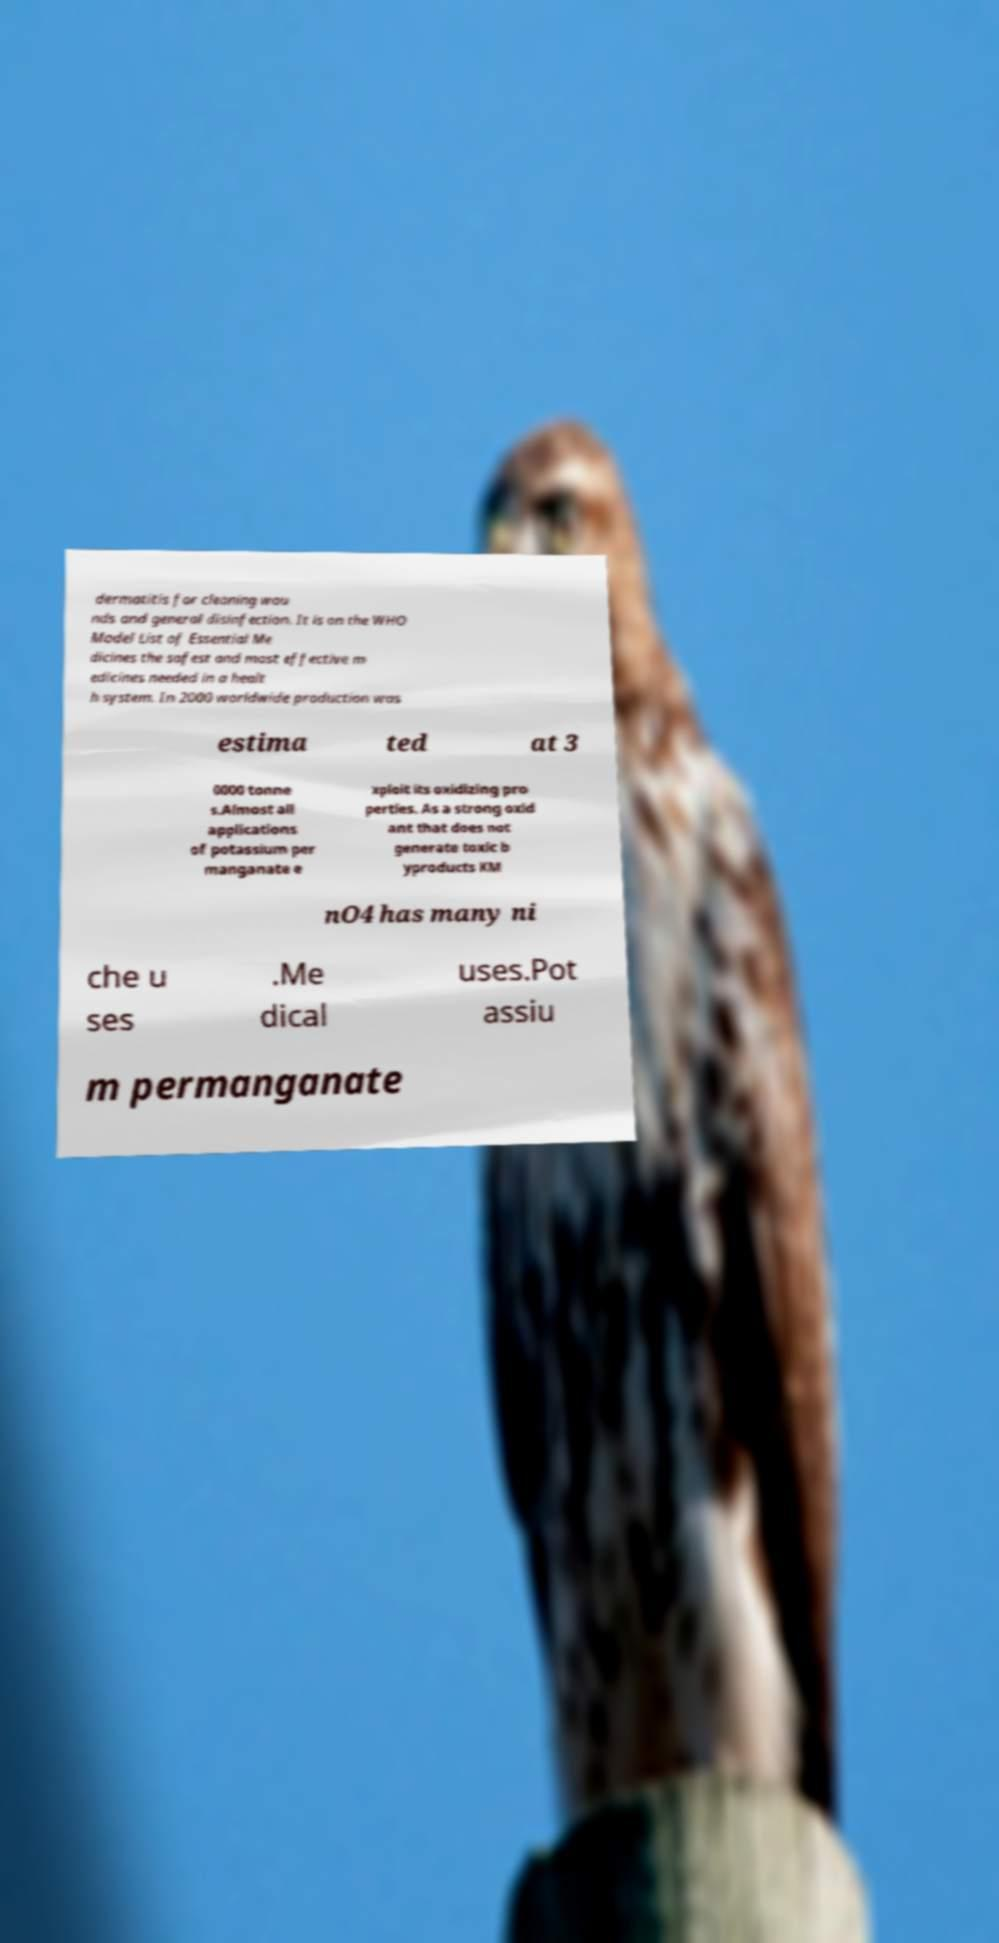Please read and relay the text visible in this image. What does it say? dermatitis for cleaning wou nds and general disinfection. It is on the WHO Model List of Essential Me dicines the safest and most effective m edicines needed in a healt h system. In 2000 worldwide production was estima ted at 3 0000 tonne s.Almost all applications of potassium per manganate e xploit its oxidizing pro perties. As a strong oxid ant that does not generate toxic b yproducts KM nO4 has many ni che u ses .Me dical uses.Pot assiu m permanganate 